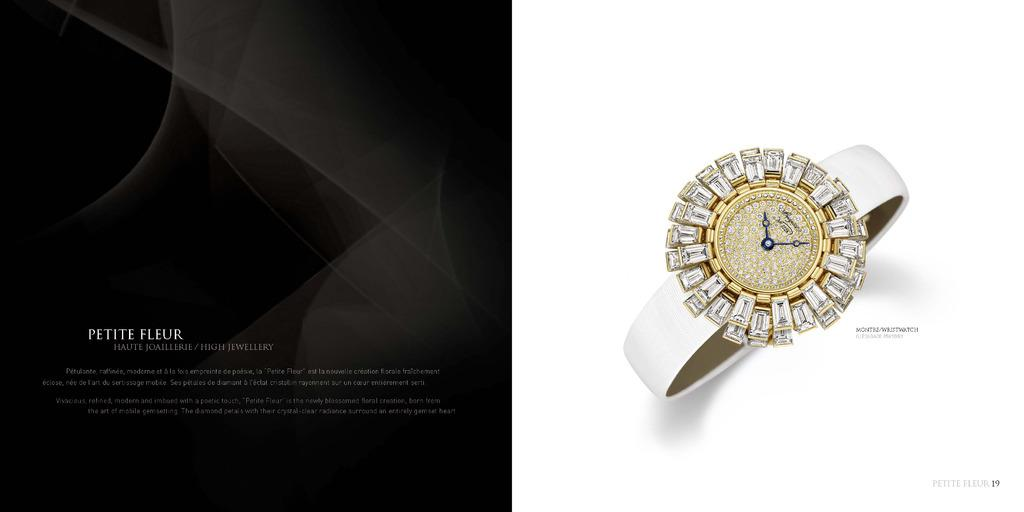Provide a one-sentence caption for the provided image. gold and diamond breguet no 3228 wristwatch by petite fleur. 